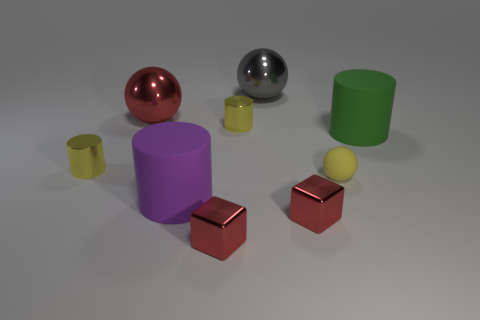Subtract all cyan balls. How many yellow cylinders are left? 2 Subtract all large metal balls. How many balls are left? 1 Subtract all brown cylinders. Subtract all brown cubes. How many cylinders are left? 4 Subtract all tiny rubber things. Subtract all green matte objects. How many objects are left? 7 Add 1 tiny yellow spheres. How many tiny yellow spheres are left? 2 Add 3 tiny metal cylinders. How many tiny metal cylinders exist? 5 Subtract 0 blue cylinders. How many objects are left? 9 Subtract all balls. How many objects are left? 6 